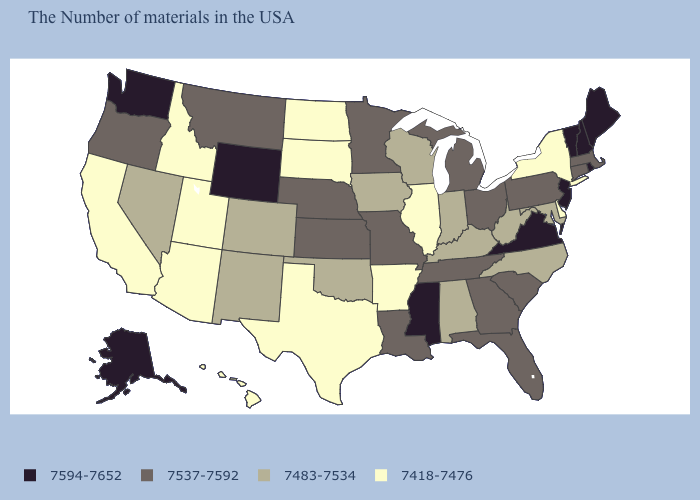Which states have the highest value in the USA?
Short answer required. Maine, Rhode Island, New Hampshire, Vermont, New Jersey, Virginia, Mississippi, Wyoming, Washington, Alaska. Among the states that border West Virginia , does Virginia have the highest value?
Keep it brief. Yes. What is the value of New York?
Concise answer only. 7418-7476. What is the lowest value in the West?
Answer briefly. 7418-7476. Among the states that border Wisconsin , which have the highest value?
Be succinct. Michigan, Minnesota. Is the legend a continuous bar?
Write a very short answer. No. Which states hav the highest value in the South?
Keep it brief. Virginia, Mississippi. Which states have the lowest value in the USA?
Answer briefly. New York, Delaware, Illinois, Arkansas, Texas, South Dakota, North Dakota, Utah, Arizona, Idaho, California, Hawaii. What is the value of Iowa?
Short answer required. 7483-7534. Which states hav the highest value in the South?
Quick response, please. Virginia, Mississippi. Does the first symbol in the legend represent the smallest category?
Short answer required. No. Does Oregon have the same value as Rhode Island?
Concise answer only. No. Does North Carolina have the lowest value in the South?
Write a very short answer. No. What is the lowest value in states that border Massachusetts?
Concise answer only. 7418-7476. Which states have the lowest value in the Northeast?
Short answer required. New York. 